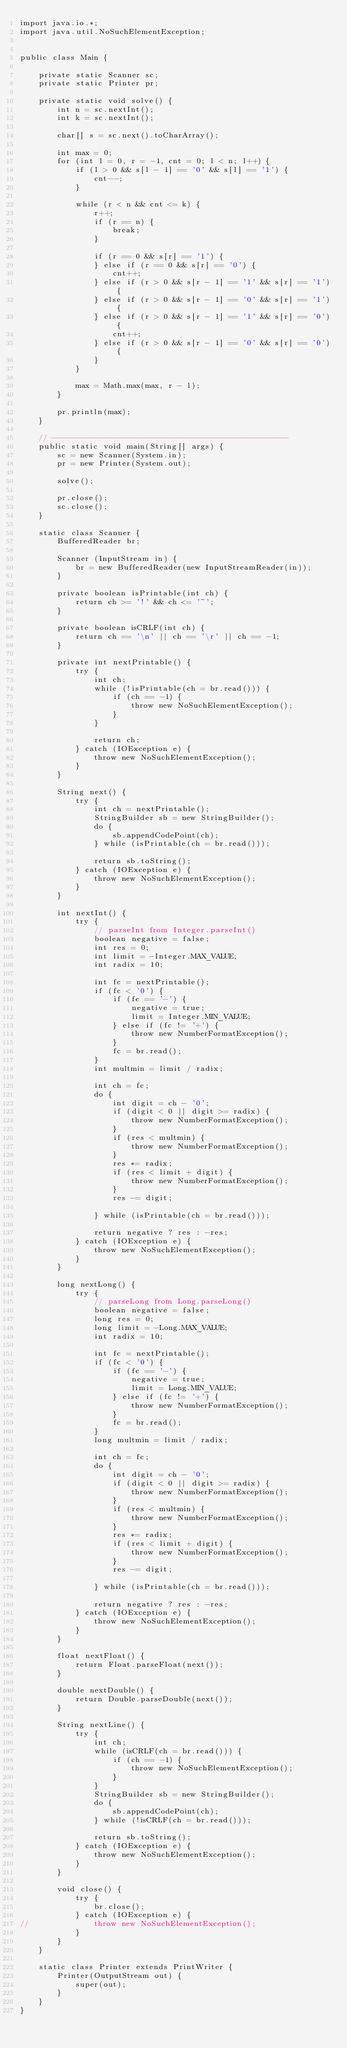<code> <loc_0><loc_0><loc_500><loc_500><_Java_>import java.io.*;
import java.util.NoSuchElementException;


public class Main {

	private static Scanner sc;
	private static Printer pr;

	private static void solve() {
		int n = sc.nextInt();
		int k = sc.nextInt();
		
		char[] s = sc.next().toCharArray();

		int max = 0;
		for (int l = 0, r = -1, cnt = 0; l < n; l++) {
			if (l > 0 && s[l - 1] == '0' && s[l] == '1') {
				cnt--;
			}
			
			while (r < n && cnt <= k) {
				r++;
				if (r == n) {
					break;
				}
				
				if (r == 0 && s[r] == '1') {
				} else if (r == 0 && s[r] == '0') {
					cnt++;
				} else if (r > 0 && s[r - 1] == '1' && s[r] == '1') {
				} else if (r > 0 && s[r - 1] == '0' && s[r] == '1') {
				} else if (r > 0 && s[r - 1] == '1' && s[r] == '0') {
					cnt++;
				} else if (r > 0 && s[r - 1] == '0' && s[r] == '0') {
				}
			}
			
			max = Math.max(max, r - l);
		}

		pr.println(max);
	}

	// ---------------------------------------------------
	public static void main(String[] args) {
		sc = new Scanner(System.in);
		pr = new Printer(System.out);
			
		solve();
			
		pr.close();
		sc.close();
	}

	static class Scanner {
		BufferedReader br;

		Scanner (InputStream in) {
			br = new BufferedReader(new InputStreamReader(in));
		}

		private boolean isPrintable(int ch) {
			return ch >= '!' && ch <= '~';
		}

		private boolean isCRLF(int ch) {
			return ch == '\n' || ch == '\r' || ch == -1;
		}

		private int nextPrintable() {
			try {
				int ch;
				while (!isPrintable(ch = br.read())) {
					if (ch == -1) {
						throw new NoSuchElementException();
					}
				}

				return ch;
			} catch (IOException e) {
				throw new NoSuchElementException();
			}
		}

		String next() {
			try {
				int ch = nextPrintable();
				StringBuilder sb = new StringBuilder();
				do {
					sb.appendCodePoint(ch);
				} while (isPrintable(ch = br.read()));

				return sb.toString();
			} catch (IOException e) {
				throw new NoSuchElementException();
			}
		}

		int nextInt() {
			try {
				// parseInt from Integer.parseInt()
				boolean negative = false;
				int res = 0;
				int limit = -Integer.MAX_VALUE;
				int radix = 10;

				int fc = nextPrintable();
				if (fc < '0') {
					if (fc == '-') {
						negative = true;
						limit = Integer.MIN_VALUE;
					} else if (fc != '+') {
						throw new NumberFormatException();
					}
					fc = br.read();
				}
				int multmin = limit / radix;

				int ch = fc;
				do {
					int digit = ch - '0';
					if (digit < 0 || digit >= radix) {
						throw new NumberFormatException();
					}
					if (res < multmin) {
						throw new NumberFormatException();
					}
					res *= radix;
					if (res < limit + digit) {
						throw new NumberFormatException();
					}
					res -= digit;

				} while (isPrintable(ch = br.read()));

				return negative ? res : -res;
			} catch (IOException e) {
				throw new NoSuchElementException();
			}
		}

		long nextLong() {
			try {
				// parseLong from Long.parseLong()
				boolean negative = false;
				long res = 0;
				long limit = -Long.MAX_VALUE;
				int radix = 10;

				int fc = nextPrintable();
				if (fc < '0') {
					if (fc == '-') {
						negative = true;
						limit = Long.MIN_VALUE;
					} else if (fc != '+') {
						throw new NumberFormatException();
					}
					fc = br.read();
				}
				long multmin = limit / radix;

				int ch = fc;
				do {
					int digit = ch - '0';
					if (digit < 0 || digit >= radix) {
						throw new NumberFormatException();
					}
					if (res < multmin) {
						throw new NumberFormatException();
					}
					res *= radix;
					if (res < limit + digit) {
						throw new NumberFormatException();
					}
					res -= digit;

				} while (isPrintable(ch = br.read()));

				return negative ? res : -res;
			} catch (IOException e) {
				throw new NoSuchElementException();
			}
		}

		float nextFloat() {
			return Float.parseFloat(next());
		}

		double nextDouble() {
			return Double.parseDouble(next());
		}

		String nextLine() {
			try {
				int ch;
				while (isCRLF(ch = br.read())) {
					if (ch == -1) {
						throw new NoSuchElementException();
					}
				}
				StringBuilder sb = new StringBuilder();
				do {
					sb.appendCodePoint(ch);
				} while (!isCRLF(ch = br.read()));

				return sb.toString();
			} catch (IOException e) {
				throw new NoSuchElementException();
			}
		}

		void close() {
			try {
				br.close();
			} catch (IOException e) {
//				throw new NoSuchElementException();
			}
		}
	}

	static class Printer extends PrintWriter {
		Printer(OutputStream out) {
			super(out);
		}
	}
}
</code> 